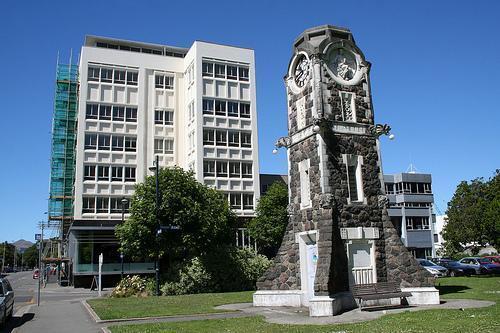How many doors can you see on the monument?
Give a very brief answer. 2. 